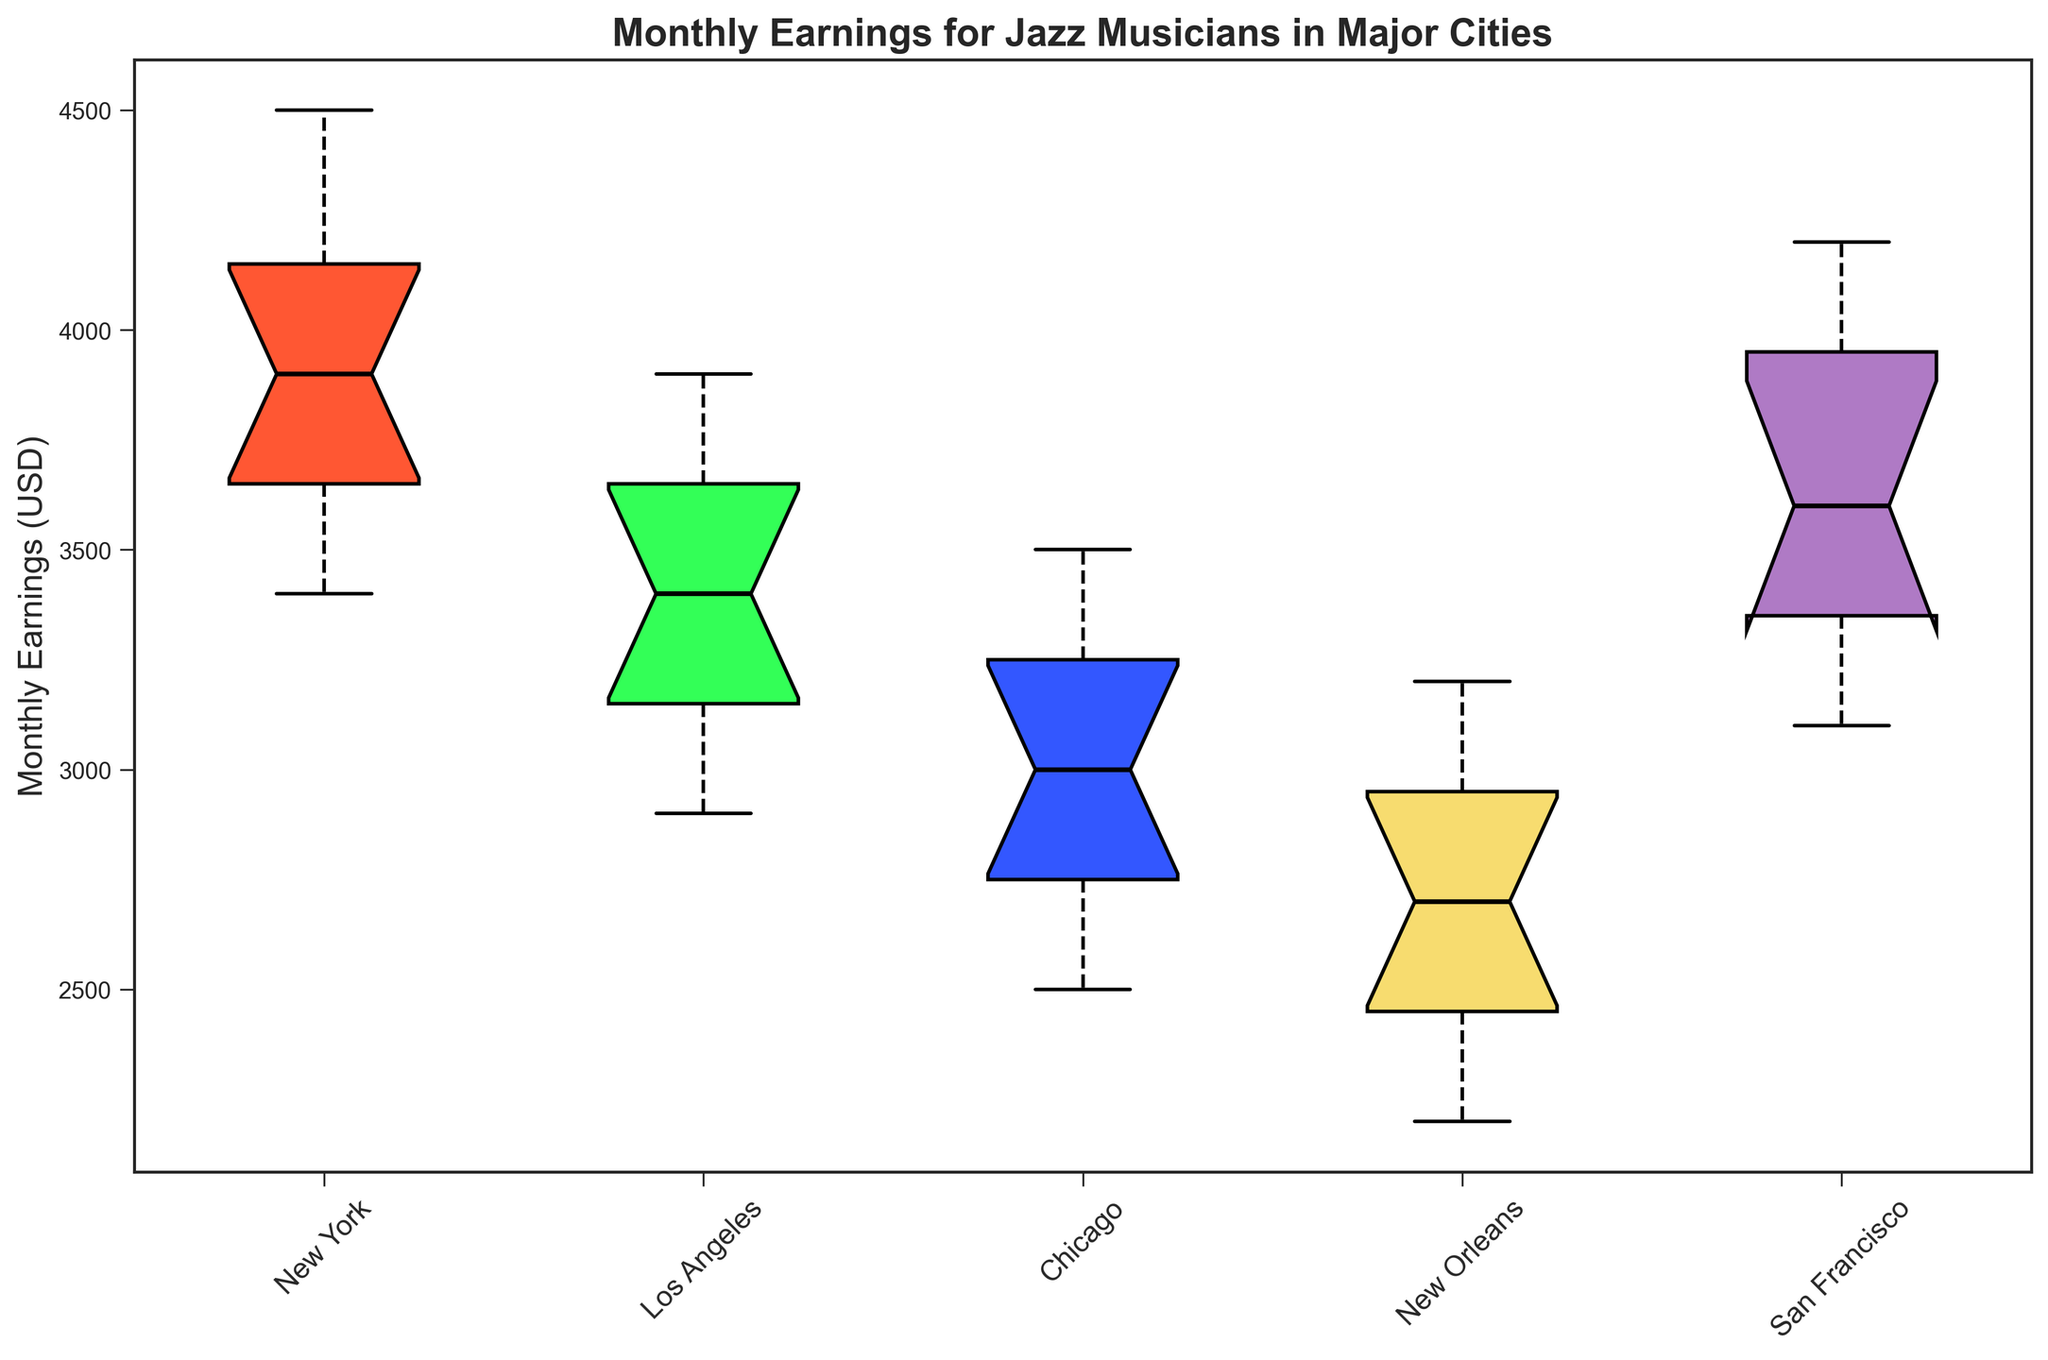What is the median monthly earning for jazz musicians in New York? The median is the middle value in a sorted list. From the box plot, look at the line inside the box for New York’s data.
Answer: 3850 Which city has the highest median monthly earnings for jazz musicians? To find the city with the highest median, compare the lines within the boxes of all cities. The box representing Los Angeles has the highest median line.
Answer: Los Angeles What is the interquartile range (IQR) for Chicago? The IQR is the difference between the first quartile (25th percentile) and the third quartile (75th percentile). Look at the top and bottom lines of the box for Chicago. Subtract the lower value from the higher value.
Answer: 1000 Between Los Angeles and San Francisco, which city has a wider range of monthly earnings? Range is determined by the distance between the upper whisker and the lower whisker. Compare the whiskers’ length in the box plots of both cities. San Francisco has a wider range.
Answer: San Francisco Which city’s jazz musicians have the lowest minimum monthly earnings? The minimum is identified by the bottommost whisker of each city. Compare the lowest points of the whiskers. New Orleans has the lowest minimum earnings.
Answer: New Orleans Is the median monthly earning for jazz musicians in San Francisco greater than that in Chicago? Compare the median lines within the boxes of San Francisco and Chicago, the line for San Francisco is higher.
Answer: Yes How many cities have their third quartile (75th percentile) above 3500? The third quartile is the top line of each box. Count the cities where this line is above 3500. New York, Los Angeles, and San Francisco each have their 75th percentile above 3500.
Answer: 3 Which city shows the most variability in monthly earnings? Variability can be assessed by the length of the whiskers and the spread of the interquartile range (IQR). The city with the largest distance between the whiskers and a large IQR displays most variability. New York shows the most variability.
Answer: New York 